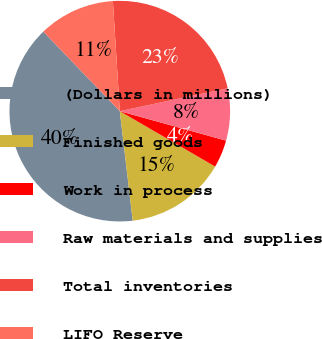Convert chart. <chart><loc_0><loc_0><loc_500><loc_500><pie_chart><fcel>(Dollars in millions)<fcel>Finished goods<fcel>Work in process<fcel>Raw materials and supplies<fcel>Total inventories<fcel>LIFO Reserve<nl><fcel>39.68%<fcel>14.75%<fcel>4.07%<fcel>7.63%<fcel>22.67%<fcel>11.19%<nl></chart> 